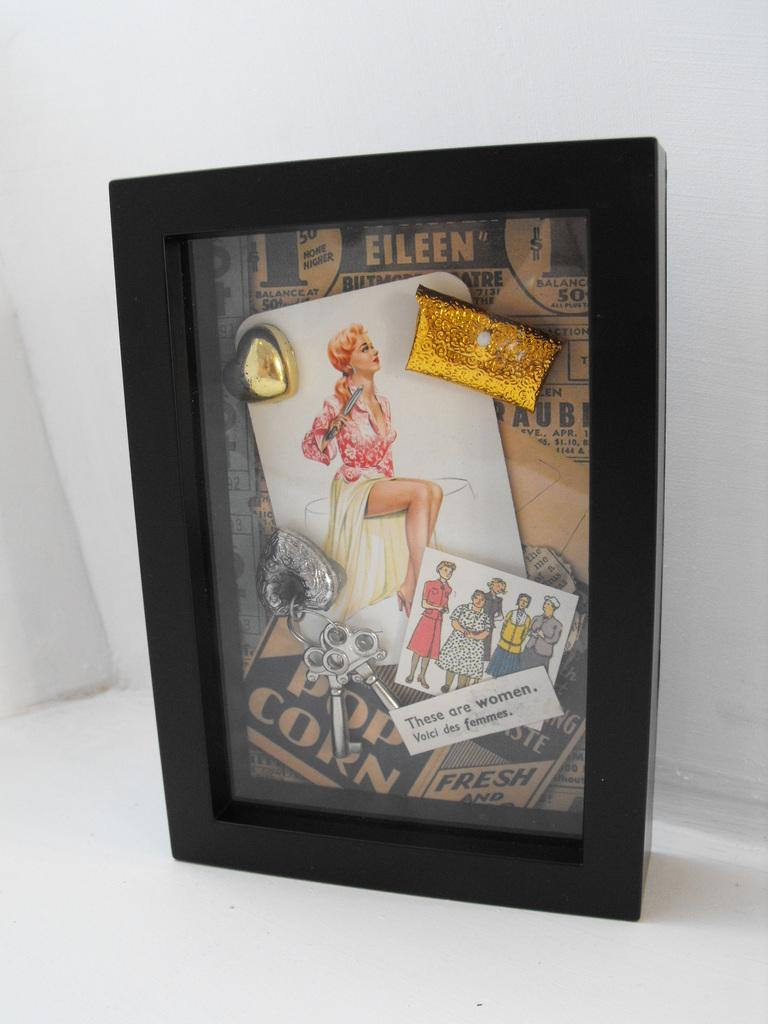<image>
Present a compact description of the photo's key features. Picture frame showing a woman under the word Eileen. 